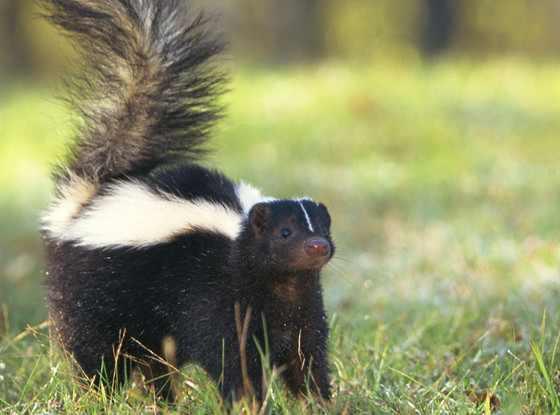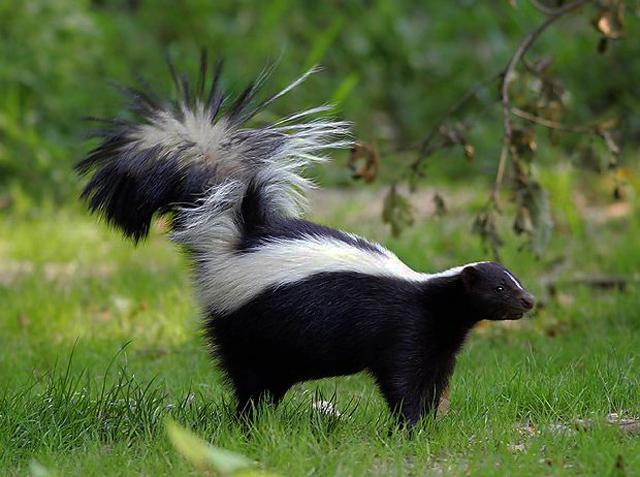The first image is the image on the left, the second image is the image on the right. For the images displayed, is the sentence "A skunk is facing to the right in one image and a skunk is facing to the left in another image." factually correct? Answer yes or no. No. 